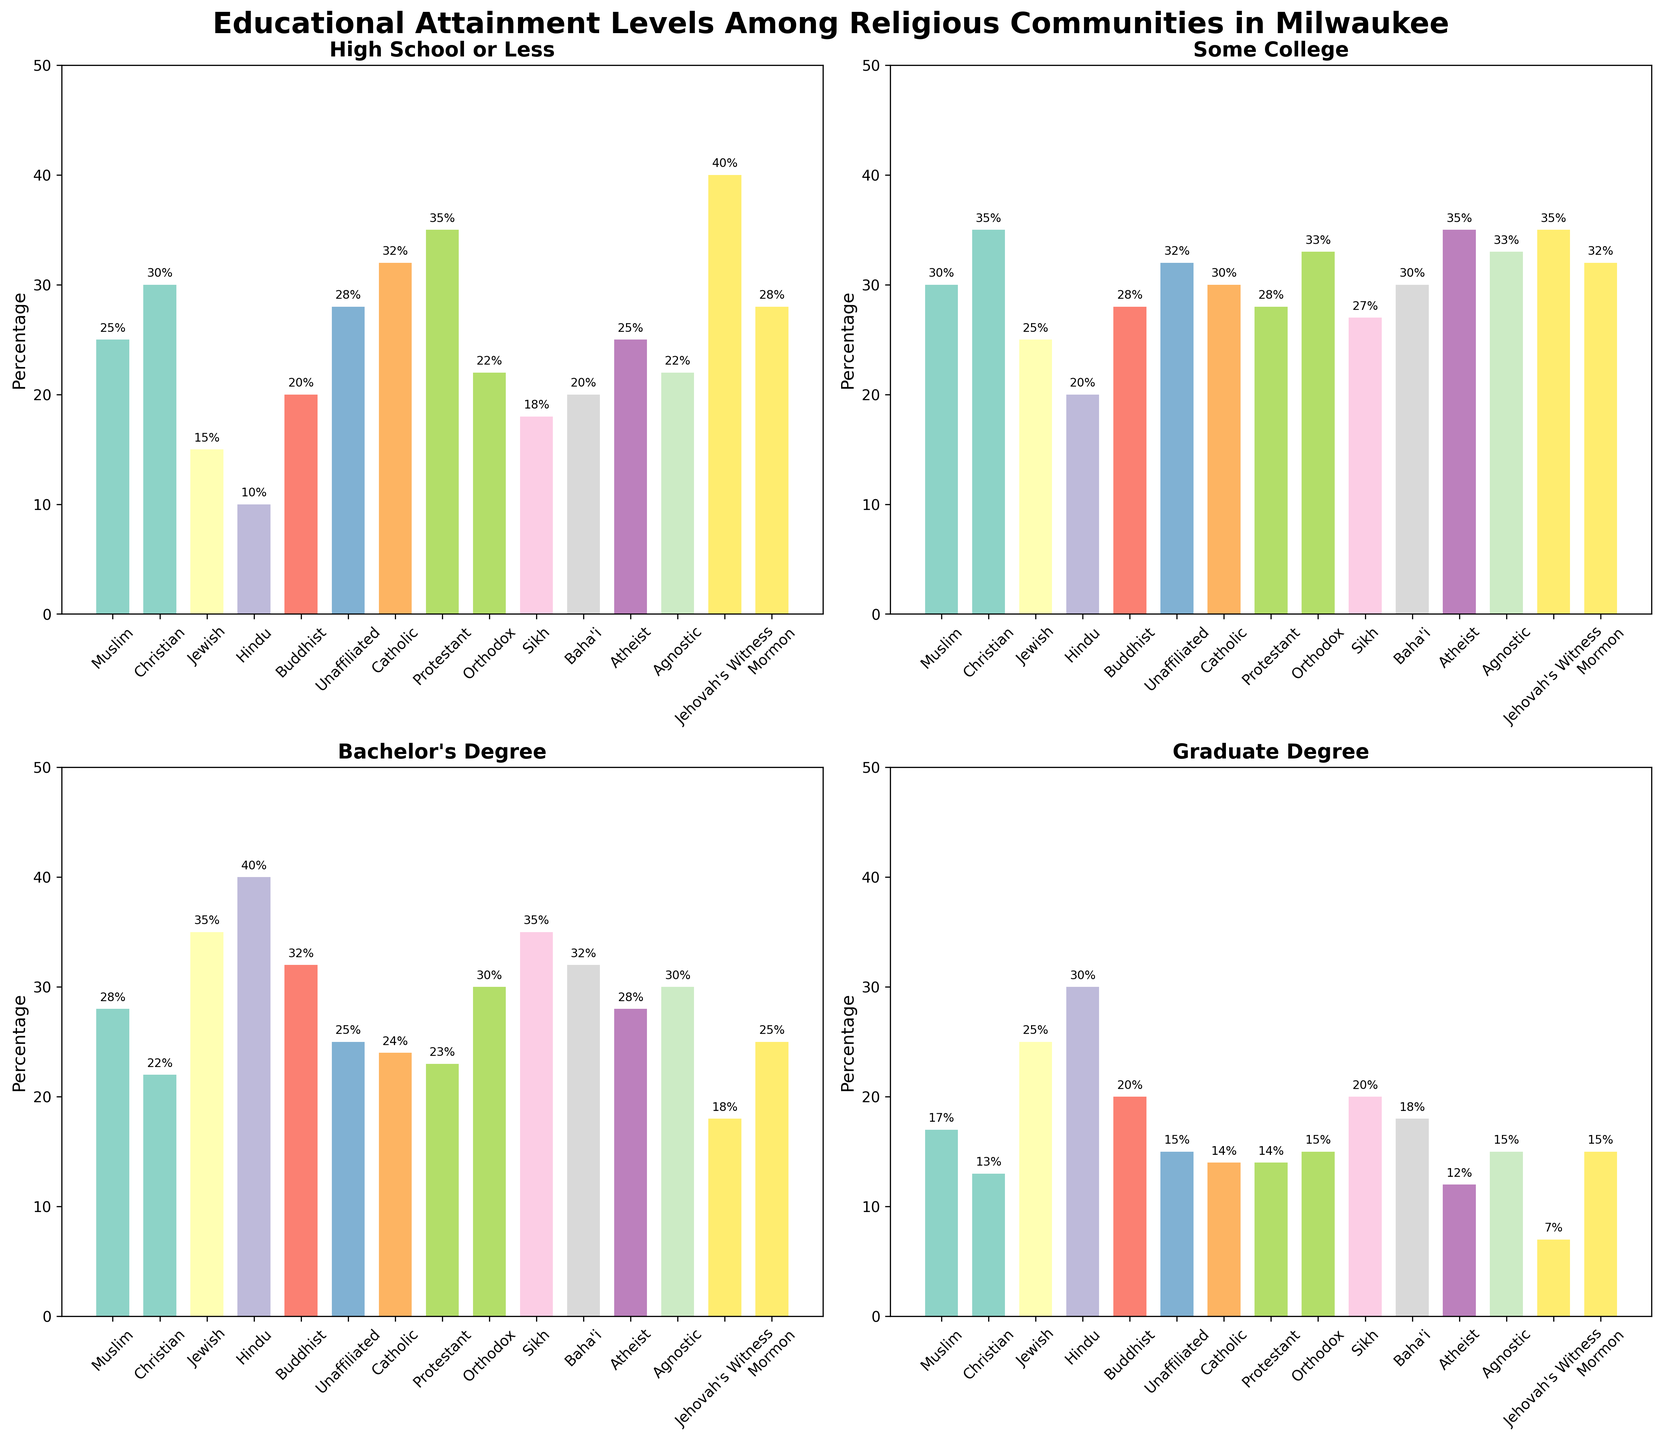What's the range of "Some College" attainment percentage among the religious communities? Identify the highest and lowest percentages in the "Some College" category. Jewish community has the highest with 33%, while Hindu community has the lowest with 20%. The range is 33 - 20
Answer: 13 Which religious community has the highest percentage of people with "Graduate Degree"? Look at the "Graduate Degree" subplot. Hindu community has the highest percentage at 30%.
Answer: Hindu How does the Muslim community compare to the Christian community in terms of "Bachelor's Degree" attainment? Check the values in the "Bachelor's Degree" subplot for both communities. Muslims have 28% while Christians have 22%. Muslims have a higher percentage.
Answer: Muslims have a higher percentage (28% vs 22%) What is the difference between the percentages of "High School or Less" education for Jehovah's Witness and Catholic communities? Refer to the "High School or Less" subplot and note the percentages for both communities. Jehovah's Witness has 40% and Catholics have 32%. The difference is 40 - 32
Answer: 8 What is the average percentage of "Graduate Degree" attainment among the Buddhist, Sikh, and Baha'i communities? Find the values in the "Graduate Degree" subplot and sum them: 20 (Buddhist) + 20 (Sikh) + 18 (Baha'i) = 58. Then, divide by 3 to get the average: 58 / 3
Answer: 19.33 Which religious community has the lowest percentage of people attaining "Some College" education? Refer to the "Some College" subplot. Hindu community has the lowest percentage at 20%.
Answer: Hindu What is the sum of the percentages for "High School or Less" and "Some College" for the Agnostic community? In the "High School or Less" subplot, Agnostic has 22%. In the "Some College" subplot, Agnostic has 33%. Sum them: 22 + 33
Answer: 55 Which community has a higher percentage of "High School or Less" attainment: Protestant or Agnostic? In the "High School or Less" subplot, Protestants have 35% and Agnostics have 22%. Protestants have a higher percentage.
Answer: Protestants How much higher is the percentage of "Bachelor's Degree" attainment in the Jewish community compared to the Unaﬃliated community? Jewish community has 35% in "Bachelor's Degree" while Unaﬃliated has 25%. The difference is 35 - 25
Answer: 10 What is the median percentage of people with "Some College" education among all religious communities? Arrange the percentages from the "Some College" subplot in order: 20, 25, 27, 28, 28, 30, 30, 30, 32, 32, 33, 33, 35, 35, 35. With 15 values, the median is the 8th value, which is 30
Answer: 30 